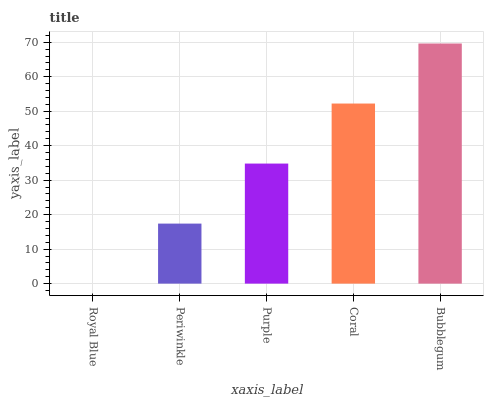Is Royal Blue the minimum?
Answer yes or no. Yes. Is Bubblegum the maximum?
Answer yes or no. Yes. Is Periwinkle the minimum?
Answer yes or no. No. Is Periwinkle the maximum?
Answer yes or no. No. Is Periwinkle greater than Royal Blue?
Answer yes or no. Yes. Is Royal Blue less than Periwinkle?
Answer yes or no. Yes. Is Royal Blue greater than Periwinkle?
Answer yes or no. No. Is Periwinkle less than Royal Blue?
Answer yes or no. No. Is Purple the high median?
Answer yes or no. Yes. Is Purple the low median?
Answer yes or no. Yes. Is Royal Blue the high median?
Answer yes or no. No. Is Coral the low median?
Answer yes or no. No. 